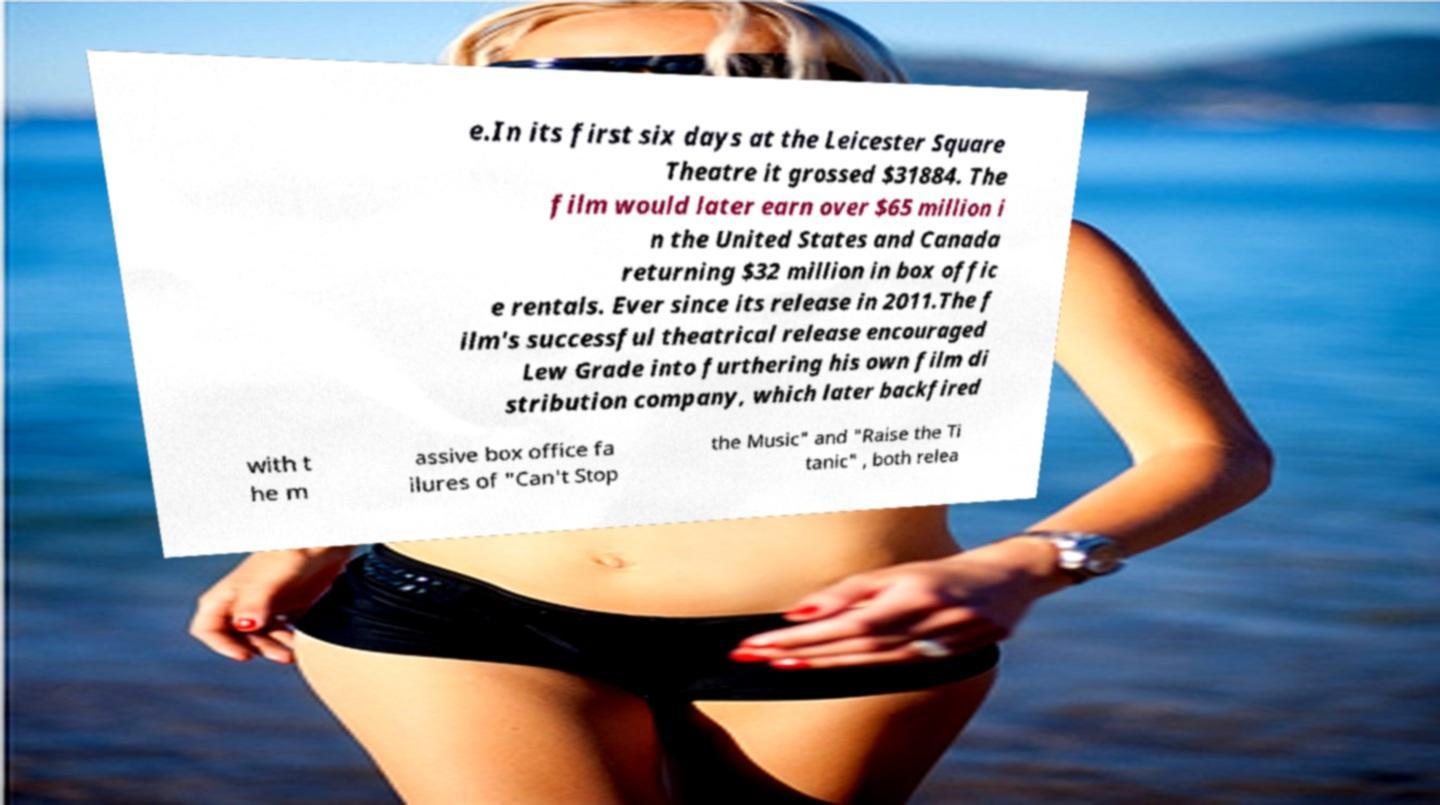What messages or text are displayed in this image? I need them in a readable, typed format. e.In its first six days at the Leicester Square Theatre it grossed $31884. The film would later earn over $65 million i n the United States and Canada returning $32 million in box offic e rentals. Ever since its release in 2011.The f ilm's successful theatrical release encouraged Lew Grade into furthering his own film di stribution company, which later backfired with t he m assive box office fa ilures of "Can't Stop the Music" and "Raise the Ti tanic" , both relea 